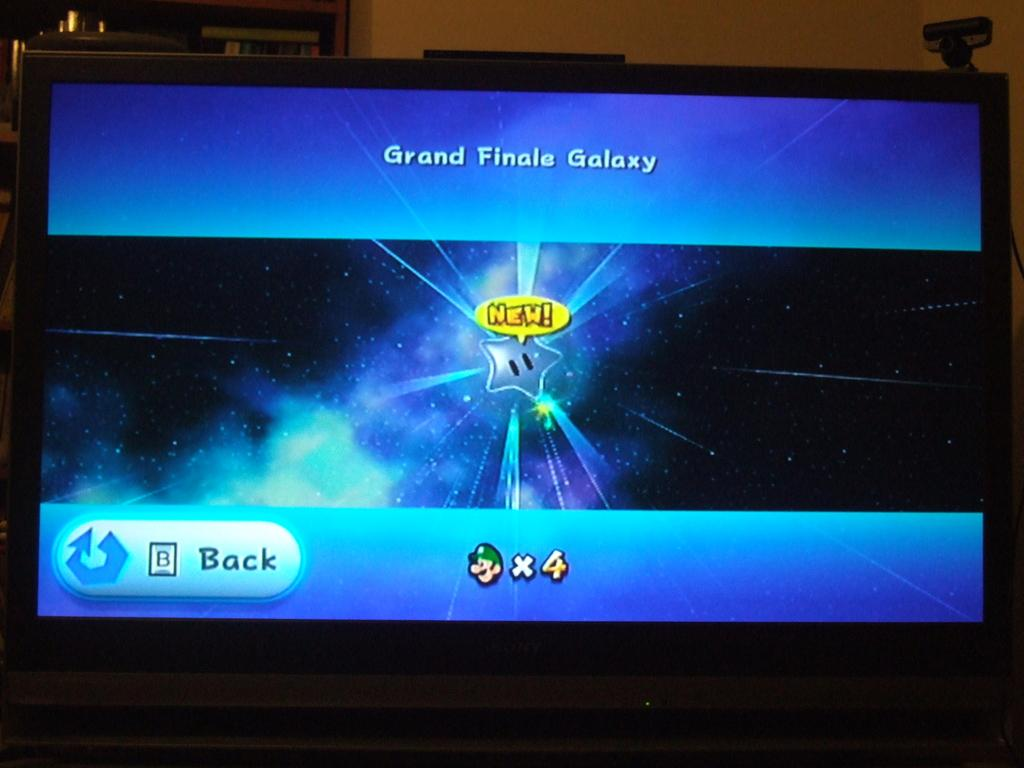<image>
Present a compact description of the photo's key features. The game on the tv screen has a star in the middle and above it says, "Grand Finale Galaxy." 